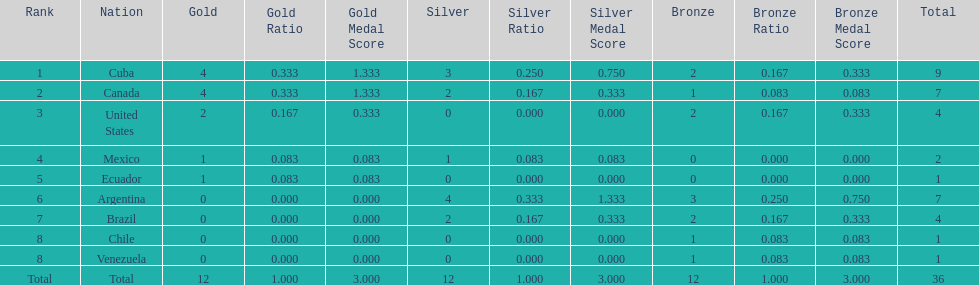How many total medals did argentina win? 7. 